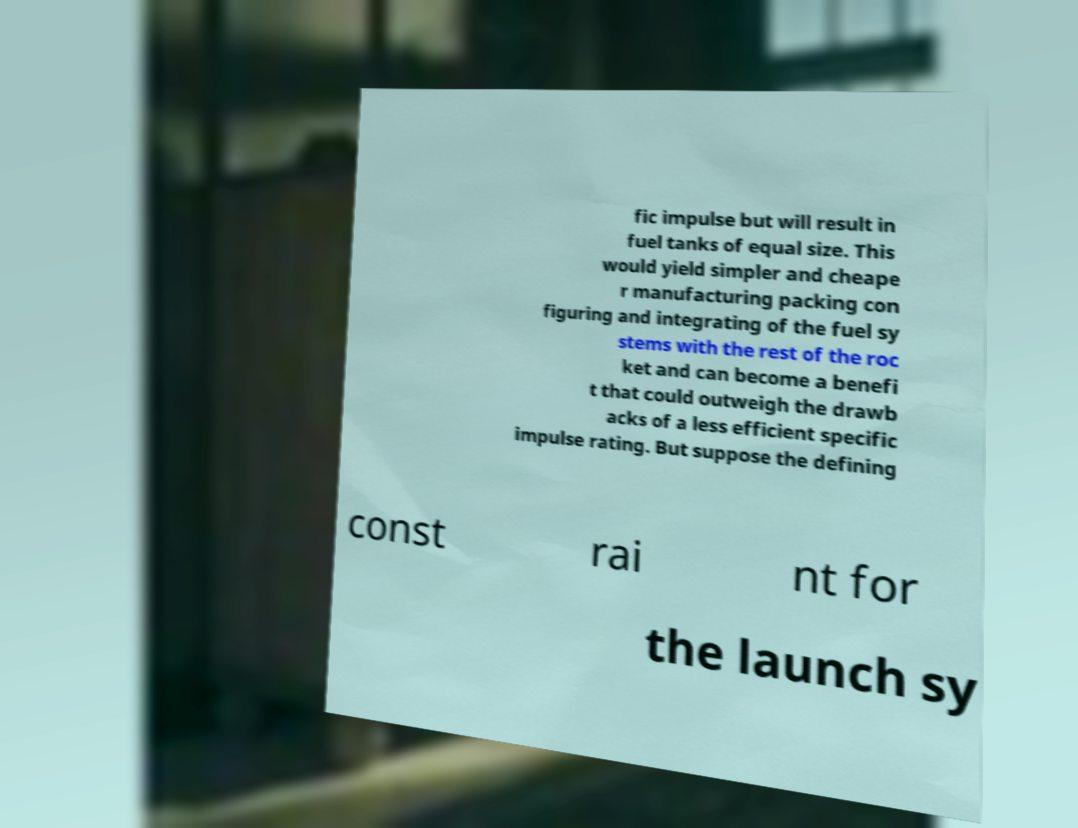There's text embedded in this image that I need extracted. Can you transcribe it verbatim? fic impulse but will result in fuel tanks of equal size. This would yield simpler and cheape r manufacturing packing con figuring and integrating of the fuel sy stems with the rest of the roc ket and can become a benefi t that could outweigh the drawb acks of a less efficient specific impulse rating. But suppose the defining const rai nt for the launch sy 